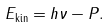Convert formula to latex. <formula><loc_0><loc_0><loc_500><loc_500>E _ { \text {kin} } = h \nu - P .</formula> 